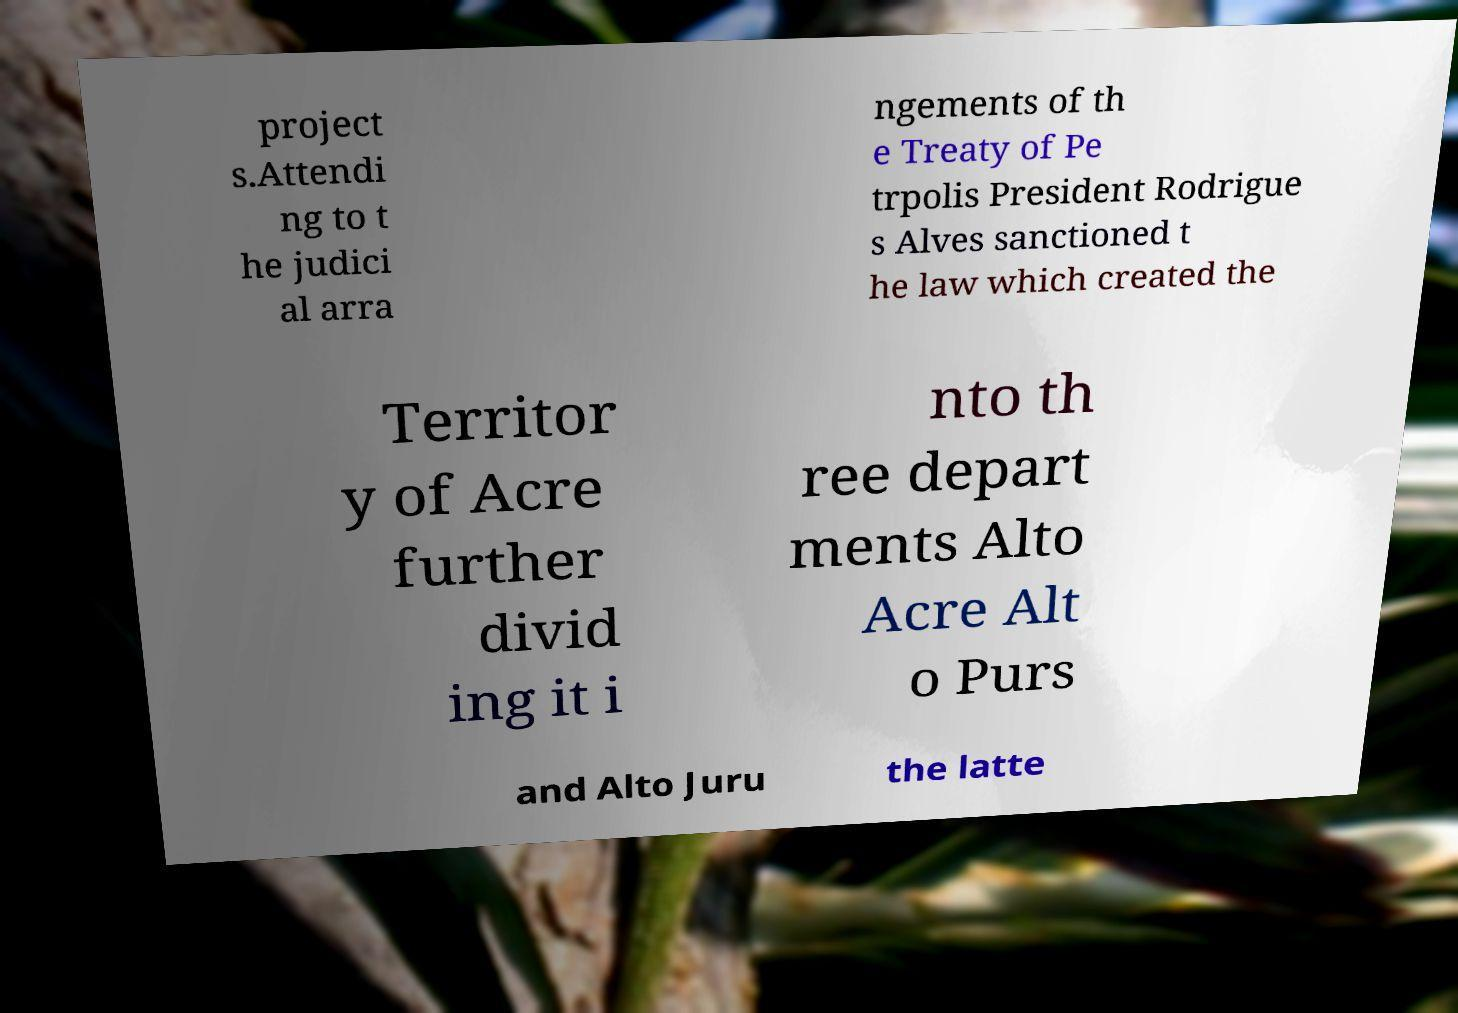What messages or text are displayed in this image? I need them in a readable, typed format. project s.Attendi ng to t he judici al arra ngements of th e Treaty of Pe trpolis President Rodrigue s Alves sanctioned t he law which created the Territor y of Acre further divid ing it i nto th ree depart ments Alto Acre Alt o Purs and Alto Juru the latte 